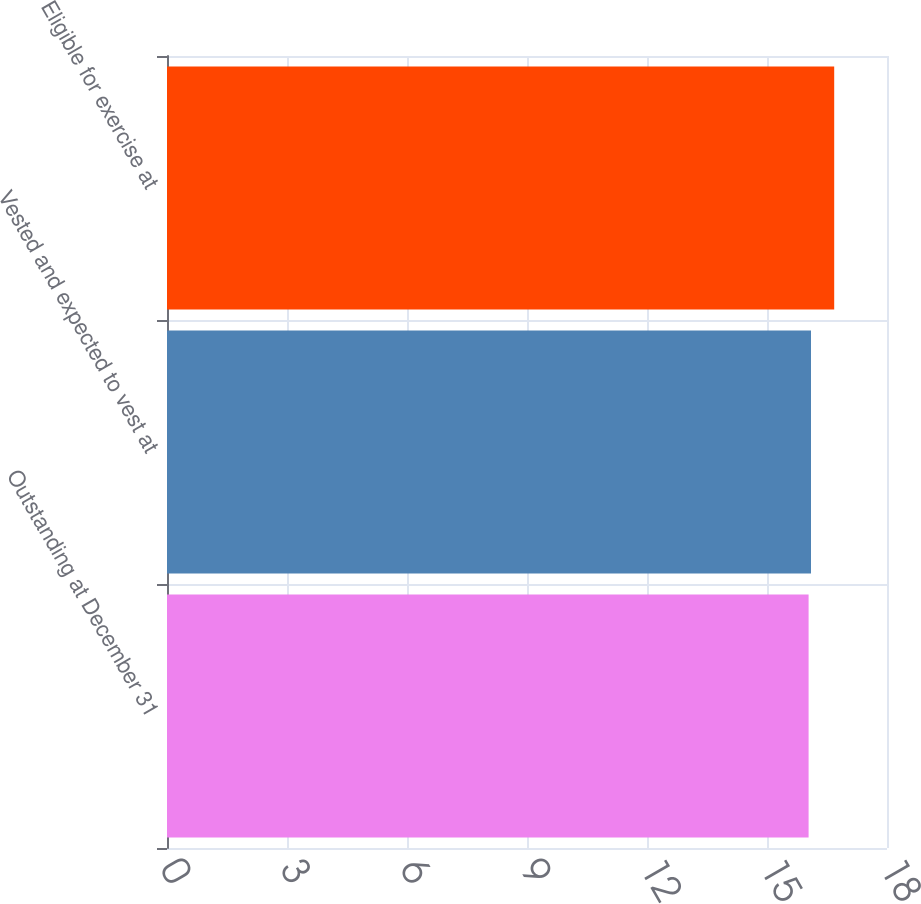<chart> <loc_0><loc_0><loc_500><loc_500><bar_chart><fcel>Outstanding at December 31<fcel>Vested and expected to vest at<fcel>Eligible for exercise at<nl><fcel>16.04<fcel>16.1<fcel>16.68<nl></chart> 